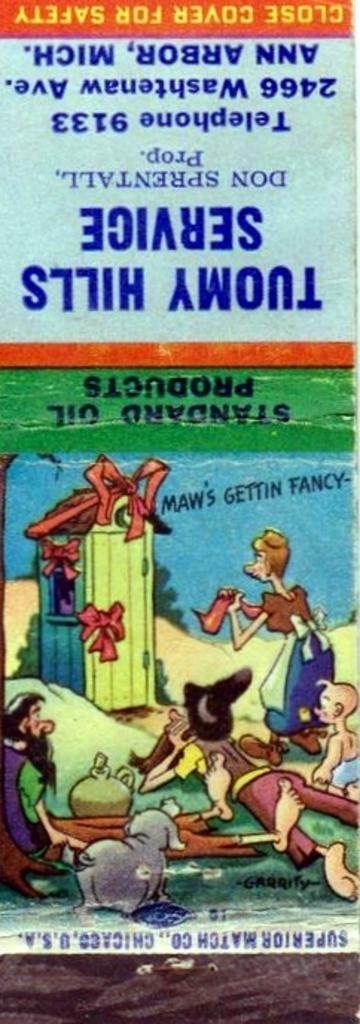<image>
Relay a brief, clear account of the picture shown. An Advertisement for Toumy Hills Service  has a close cover for safety warning on it. 